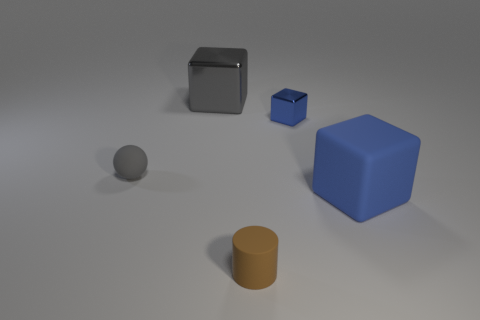The other blue thing that is the same shape as the small blue object is what size?
Make the answer very short. Large. Are there any blue cubes that are on the left side of the big cube in front of the gray block?
Your answer should be very brief. Yes. Is the tiny metal cube the same color as the big metallic block?
Ensure brevity in your answer.  No. How many other things are the same shape as the big gray shiny object?
Your response must be concise. 2. Is the number of tiny things to the left of the rubber cylinder greater than the number of small shiny blocks that are to the right of the big matte cube?
Offer a terse response. Yes. There is a metallic cube that is to the right of the small brown thing; does it have the same size as the cube in front of the sphere?
Keep it short and to the point. No. What shape is the big blue matte object?
Offer a terse response. Cube. There is a object that is the same color as the rubber ball; what is its size?
Offer a terse response. Large. What color is the other tiny cube that is the same material as the gray block?
Provide a succinct answer. Blue. Do the small block and the big object left of the large blue rubber block have the same material?
Your answer should be compact. Yes. 